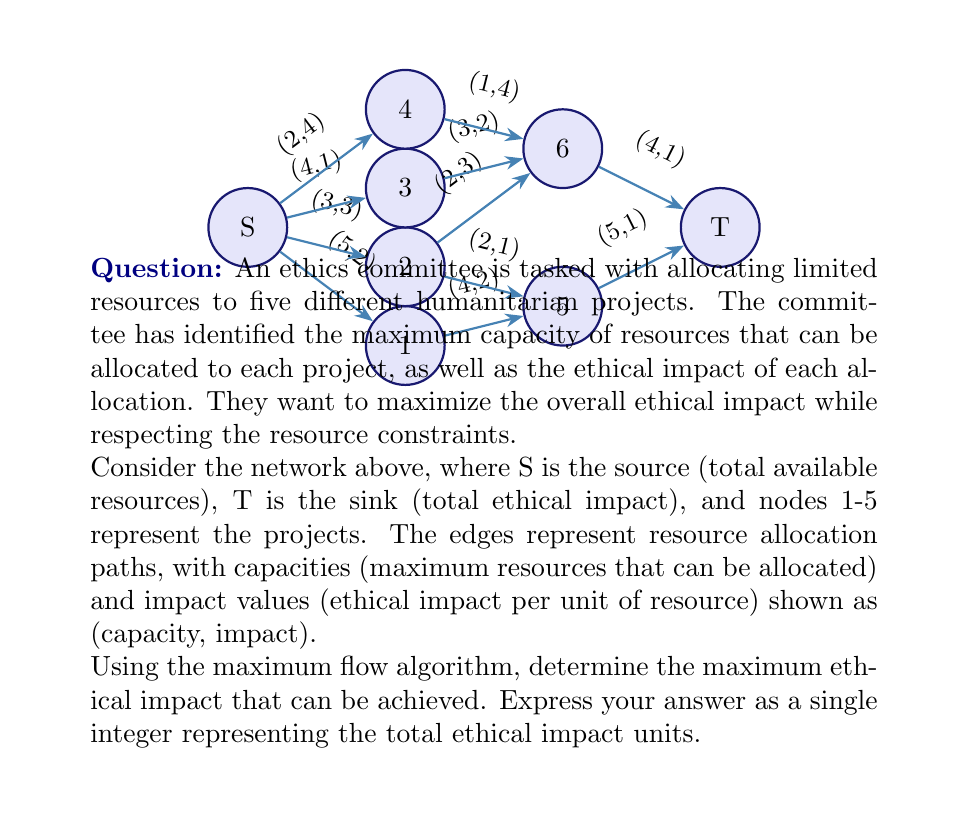Can you solve this math problem? To solve this problem, we'll use the Ford-Fulkerson algorithm to find the maximum flow in the network, which will correspond to the maximum ethical impact. The algorithm works as follows:

1. Initialize flow to 0 for all edges.
2. While there exists an augmenting path from S to T:
   a. Find the minimum capacity along the path.
   b. Augment the flow along the path by this minimum capacity.
   c. Update residual graph.
3. The maximum flow is the sum of flows out of S (or into T).

Let's apply the algorithm step by step:

Iteration 1:
Path: S → 3 → 5 → T
Min capacity: min(2, 1, 4) = 1
Flow: 1
Ethical impact: 1 * (4 + 4 + 1) = 9

Iteration 2:
Path: S → 1 → 5 → T
Min capacity: min(5, 2, 3) = 2
Flow: 2
Ethical impact: 2 * (2 + 3 + 1) = 12

Iteration 3:
Path: S → 2 → 5 → T
Min capacity: min(4, 1, 1) = 1
Flow: 1
Ethical impact: 1 * (1 + 2 + 1) = 4

Iteration 4:
Path: S → 1 → 4 → T
Min capacity: min(3, 2, 5) = 2
Flow: 2
Ethical impact: 2 * (2 + 2 + 1) = 10

Iteration 5:
Path: S → 2 → 4 → T
Min capacity: min(3, 2, 3) = 2
Flow: 2
Ethical impact: 2 * (3 + 1 + 1) = 10

No more augmenting paths exist.

The total flow is 1 + 2 + 1 + 2 + 2 = 8 units of resources.

To calculate the total ethical impact, we sum the products of flow and impact for each edge leaving S:

$$(1 * 4) + (2 * 2) + (1 * 1) + (2 * 3) + (2 * 3) = 4 + 4 + 1 + 6 + 6 = 21$$

Therefore, the maximum ethical impact that can be achieved is 21 units.
Answer: 21 